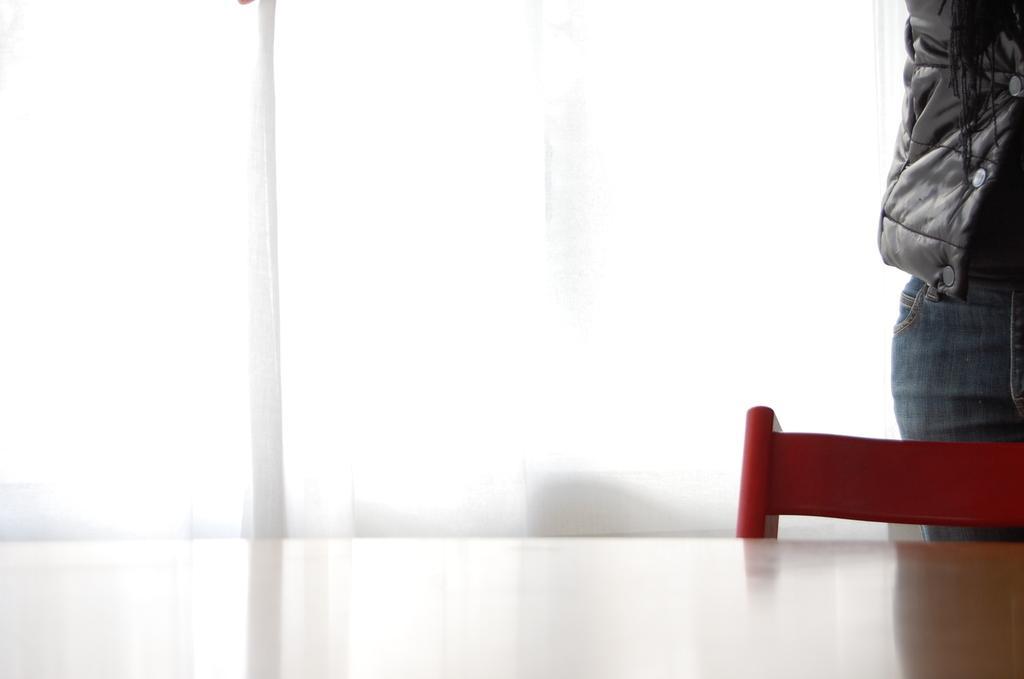In one or two sentences, can you explain what this image depicts? In this image we can see a table and a chair at the bottom. On the right side there is a person. In the back there is curtain. 